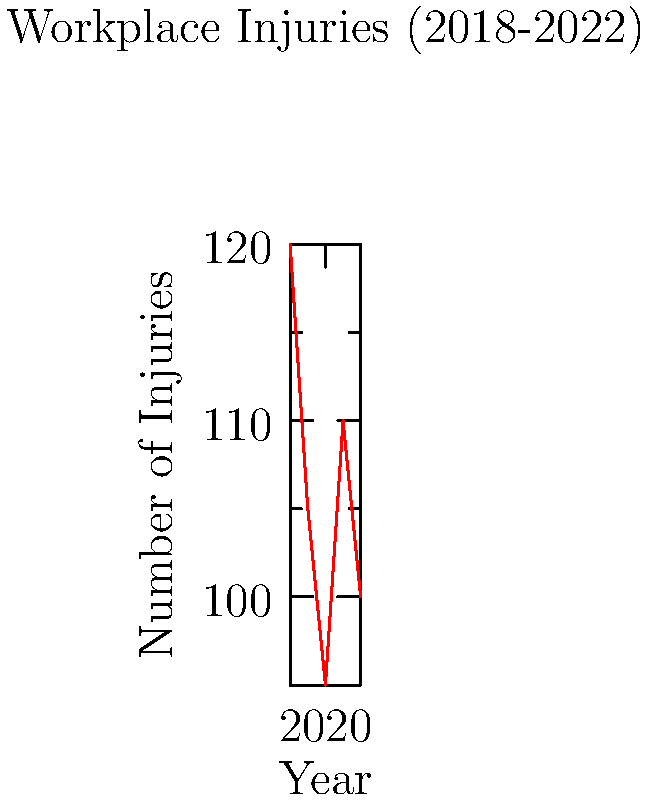Based on the line graph showing workplace injury trends from 2018 to 2022, calculate the average annual change in the number of injuries. What does this value indicate about the overall trend in workplace safety during this period? To calculate the average annual change in the number of injuries:

1. Calculate the total change from 2018 to 2022:
   $100 - 120 = -20$ injuries

2. Divide the total change by the number of years (5-1 = 4) to get the average annual change:
   $\frac{-20}{4} = -5$ injuries per year

3. Interpret the result:
   A negative value indicates an overall decreasing trend in injuries.
   On average, there were 5 fewer injuries each year from 2018 to 2022.

4. Consider the implications:
   This suggests an improvement in workplace safety over the period, although the trend is not consistently downward (there's an increase in 2021).

5. Relate to the role:
   As a public health officer, this trend indicates that implemented health policies and regulations have generally been effective, but there's still room for improvement and need for continued vigilance, especially considering the increase in 2021.
Answer: -5 injuries/year; overall improving workplace safety trend 